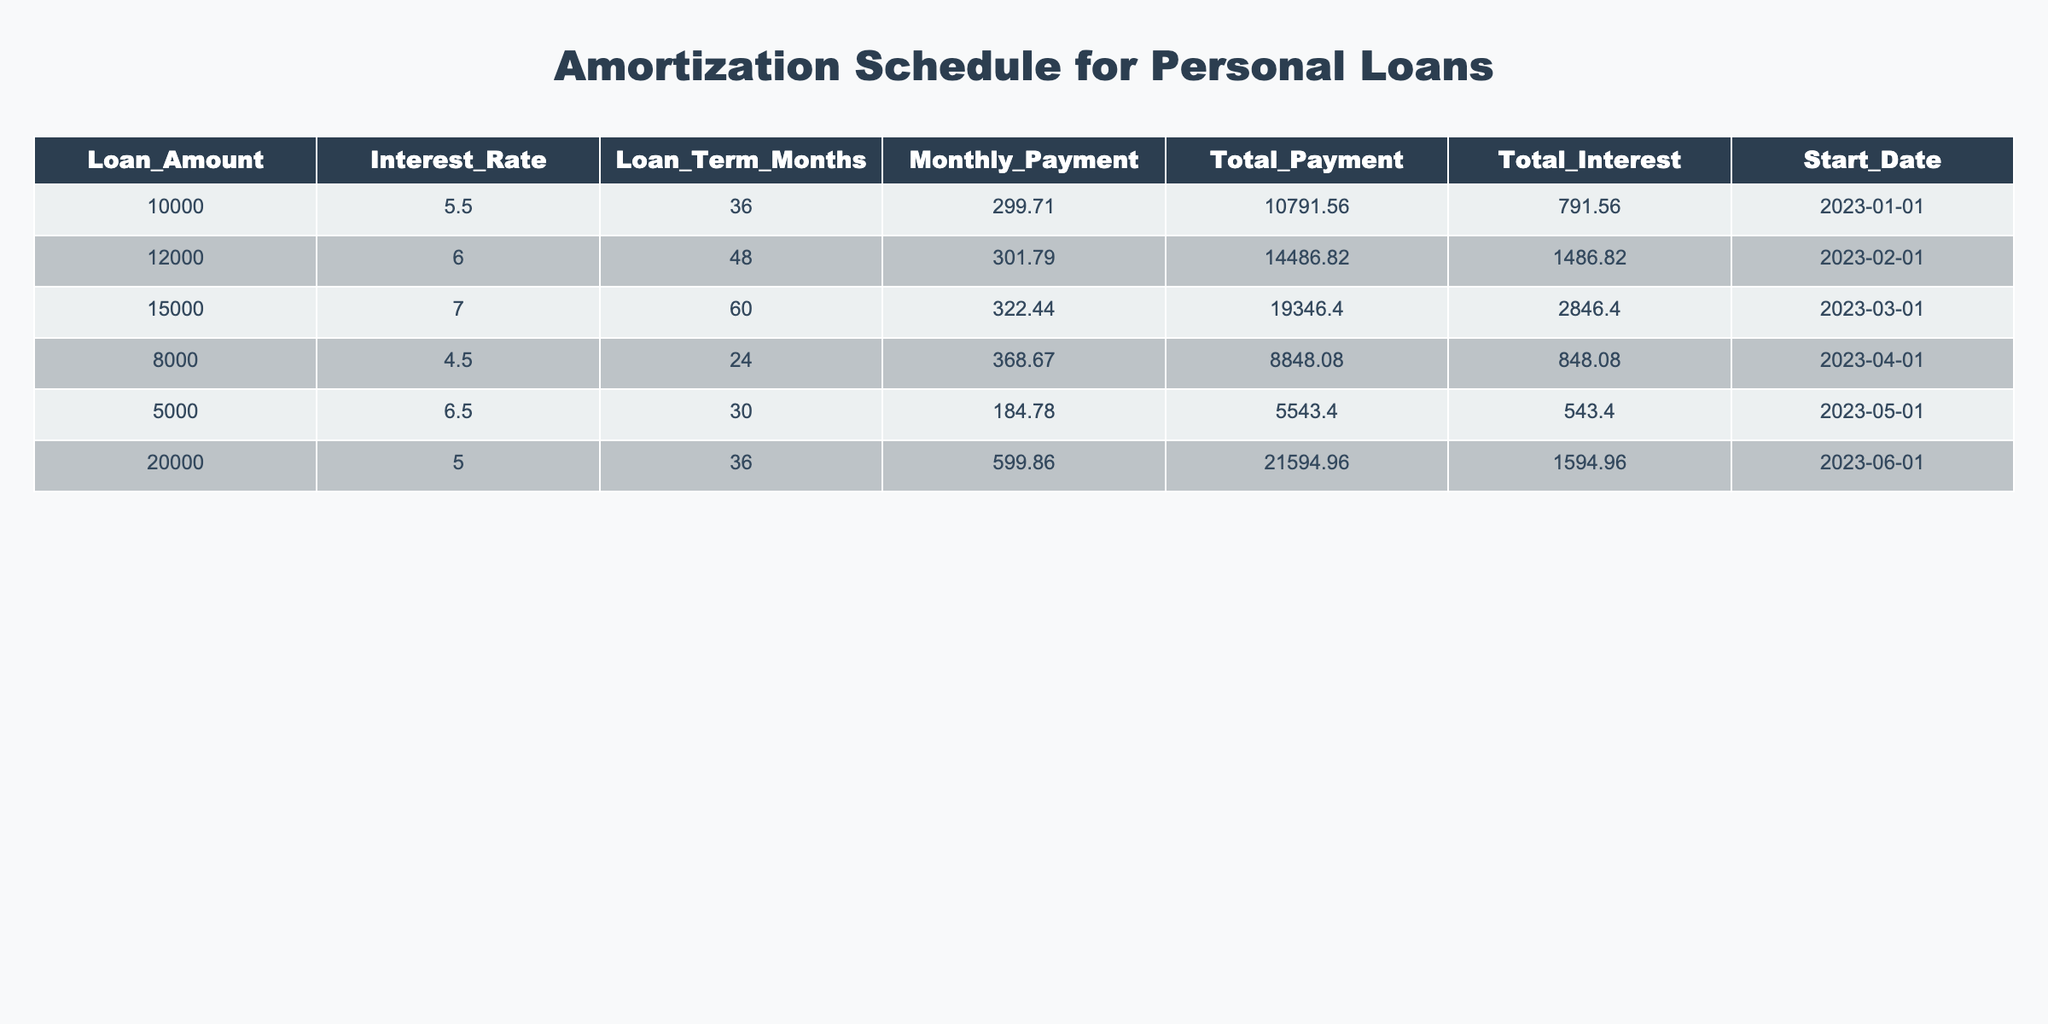What is the loan amount with the highest total interest? From the table, we can compare the total interest for each loan. The loan amounts and their corresponding total interest are: $10,000 with $791.56, $12,000 with $1,486.82, $15,000 with $2,846.40, $8,000 with $848.08, $5,000 with $543.40, and $20,000 with $1,594.96. The highest total interest is $2,846.40 for the $15,000 loan.
Answer: $15,000 What is the total payment for the loan with the lowest monthly payment? First, we examine the monthly payment for each loan. The monthly payments are $299.71, $301.79, $322.44, $368.67, $184.78, and $599.86. The lowest is $184.78, corresponding to the $5,000 loan. The total payment for this loan is $5,543.40.
Answer: $5,543.40 Does the personal loan taken in January have a higher total payment than the one taken in April? We check the total payment for the loans taken in January and April. The January loan has a total payment of $10,791.56, while the April loan has $8,848.08. Thus, $10,791.56 is greater than $8,848.08.
Answer: Yes What is the average interest rate across all loans? First, we sum the interest rates: 5.5 + 6.0 + 7.0 + 4.5 + 6.5 + 5.0 = 34.5. There are 6 loans. Thus, the average interest rate is 34.5 / 6 = 5.75.
Answer: 5.75 Which loan took the longest time to pay off? We look at the loan terms in months: 36, 48, 60, 24, 30, and 36. The longest term is 60 months for the $15,000 loan.
Answer: $15,000 Is there a loan with a monthly payment greater than $600? By reviewing the monthly payments, we find $299.71, $301.79, $322.44, $368.67, $184.78, and $599.86. None exceed $600.
Answer: No What is the difference in total payment between the $12,000 and $20,000 loans? We take the total payment for the $12,000 loan, which is $14,486.82, and subtract the total payment for the $20,000 loan, which is $21,594.96. The difference is $21,594.96 - $14,486.82 = $7,108.14.
Answer: $7,108.14 What loan had the earliest start date? The loan start dates are: January 1, February 1, March 1, April 1, May 1, and June 1. January 1 is the earliest date for the $10,000 loan.
Answer: $10,000 